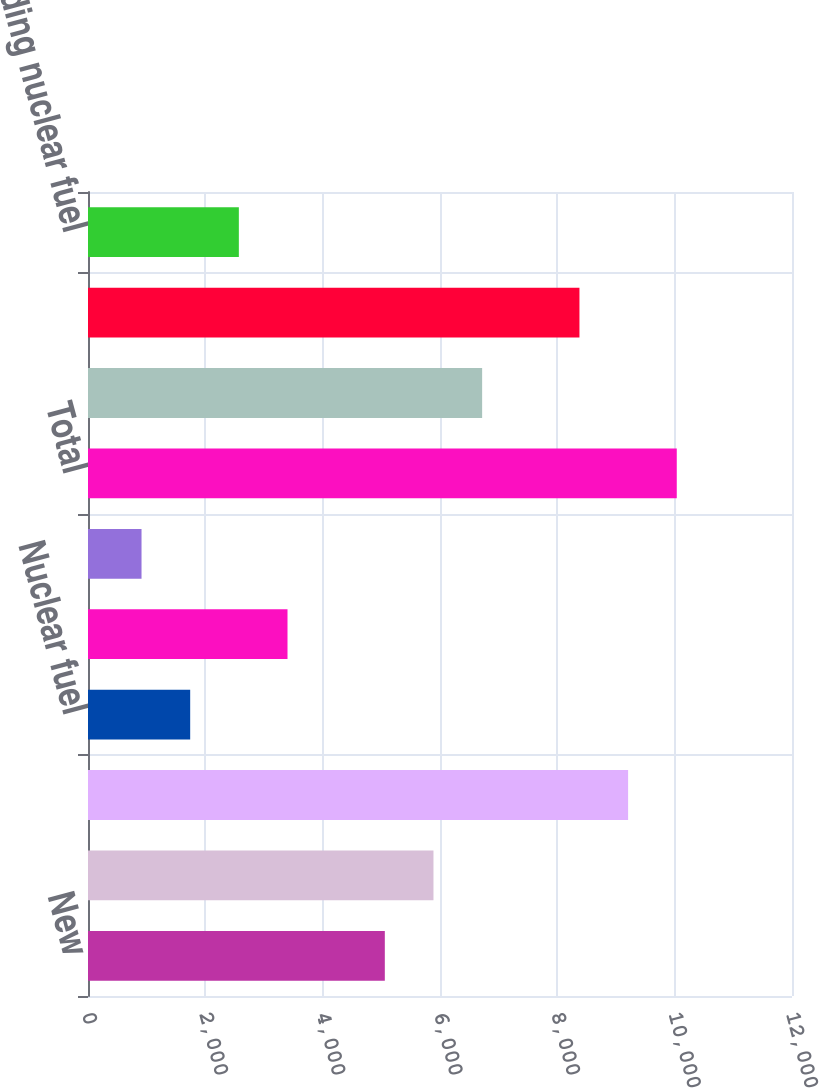<chart> <loc_0><loc_0><loc_500><loc_500><bar_chart><fcel>New<fcel>Existing<fcel>Transmission and distribution<fcel>Nuclear fuel<fcel>General and other<fcel>Other primarily change in<fcel>Total<fcel>Wind<fcel>Solar<fcel>Nuclear including nuclear fuel<nl><fcel>5059.4<fcel>5888.8<fcel>9206.4<fcel>1741.8<fcel>3400.6<fcel>912.4<fcel>10035.8<fcel>6718.2<fcel>8377<fcel>2571.2<nl></chart> 